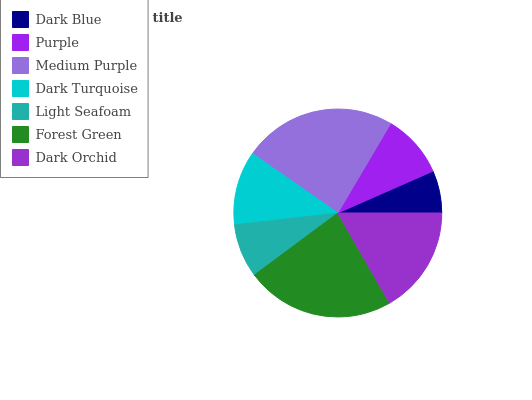Is Dark Blue the minimum?
Answer yes or no. Yes. Is Medium Purple the maximum?
Answer yes or no. Yes. Is Purple the minimum?
Answer yes or no. No. Is Purple the maximum?
Answer yes or no. No. Is Purple greater than Dark Blue?
Answer yes or no. Yes. Is Dark Blue less than Purple?
Answer yes or no. Yes. Is Dark Blue greater than Purple?
Answer yes or no. No. Is Purple less than Dark Blue?
Answer yes or no. No. Is Dark Turquoise the high median?
Answer yes or no. Yes. Is Dark Turquoise the low median?
Answer yes or no. Yes. Is Purple the high median?
Answer yes or no. No. Is Light Seafoam the low median?
Answer yes or no. No. 